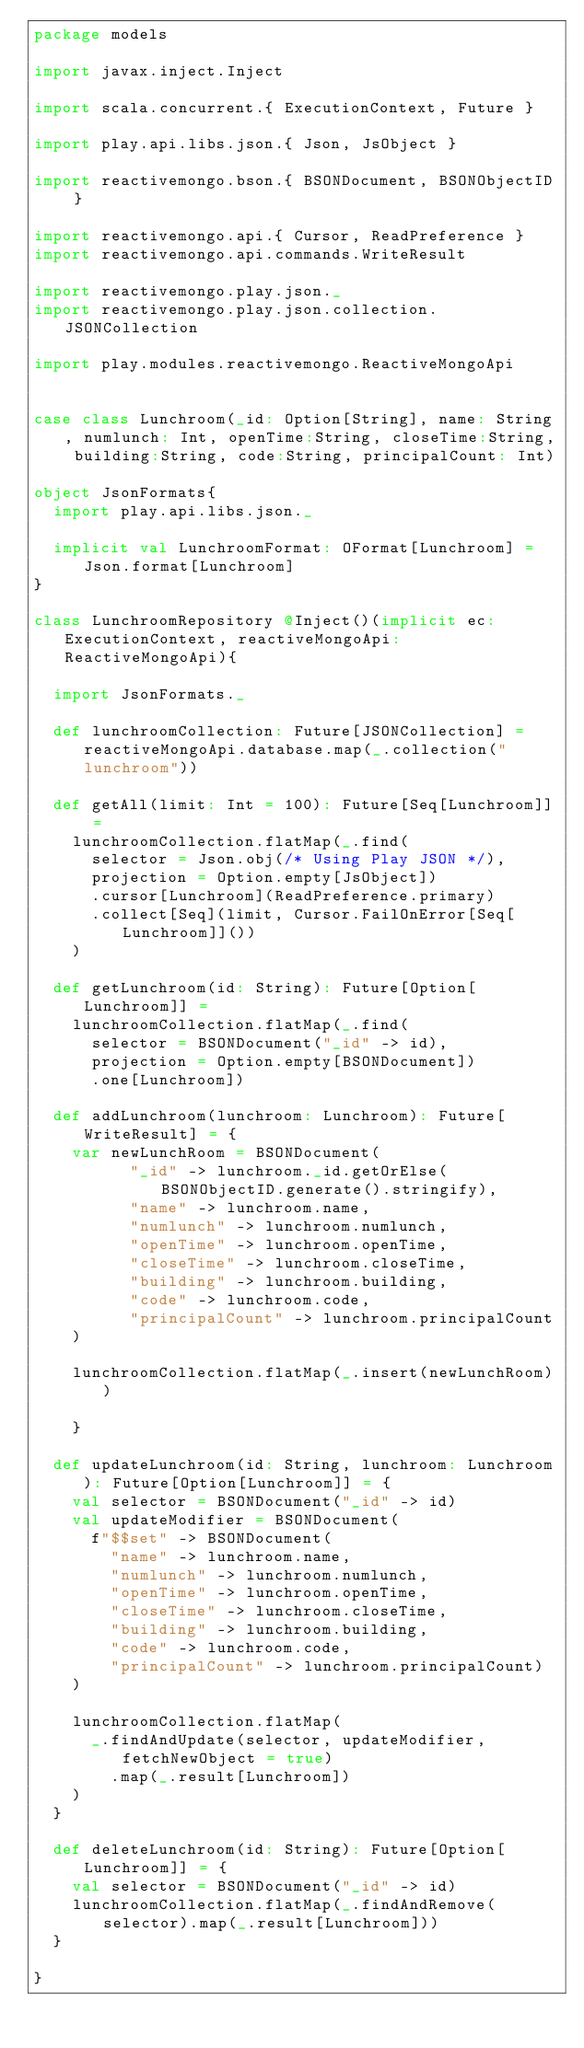<code> <loc_0><loc_0><loc_500><loc_500><_Scala_>package models

import javax.inject.Inject

import scala.concurrent.{ ExecutionContext, Future }

import play.api.libs.json.{ Json, JsObject }

import reactivemongo.bson.{ BSONDocument, BSONObjectID }

import reactivemongo.api.{ Cursor, ReadPreference }
import reactivemongo.api.commands.WriteResult

import reactivemongo.play.json._
import reactivemongo.play.json.collection.JSONCollection

import play.modules.reactivemongo.ReactiveMongoApi


case class Lunchroom(_id: Option[String], name: String, numlunch: Int, openTime:String, closeTime:String, building:String, code:String, principalCount: Int)

object JsonFormats{
  import play.api.libs.json._

  implicit val LunchroomFormat: OFormat[Lunchroom] = Json.format[Lunchroom]
}

class LunchroomRepository @Inject()(implicit ec: ExecutionContext, reactiveMongoApi: ReactiveMongoApi){

  import JsonFormats._

  def lunchroomCollection: Future[JSONCollection] = reactiveMongoApi.database.map(_.collection("lunchroom"))

  def getAll(limit: Int = 100): Future[Seq[Lunchroom]] =
    lunchroomCollection.flatMap(_.find(
      selector = Json.obj(/* Using Play JSON */),
      projection = Option.empty[JsObject])
      .cursor[Lunchroom](ReadPreference.primary)
      .collect[Seq](limit, Cursor.FailOnError[Seq[Lunchroom]]())
    )

  def getLunchroom(id: String): Future[Option[Lunchroom]] =
    lunchroomCollection.flatMap(_.find(
      selector = BSONDocument("_id" -> id),
      projection = Option.empty[BSONDocument])
      .one[Lunchroom])

  def addLunchroom(lunchroom: Lunchroom): Future[WriteResult] = {
    var newLunchRoom = BSONDocument(
          "_id" -> lunchroom._id.getOrElse(BSONObjectID.generate().stringify),
          "name" -> lunchroom.name,
          "numlunch" -> lunchroom.numlunch,
          "openTime" -> lunchroom.openTime,
          "closeTime" -> lunchroom.closeTime,
          "building" -> lunchroom.building,
          "code" -> lunchroom.code,
          "principalCount" -> lunchroom.principalCount
    )
    
    lunchroomCollection.flatMap(_.insert(newLunchRoom))

    }

  def updateLunchroom(id: String, lunchroom: Lunchroom): Future[Option[Lunchroom]] = {
    val selector = BSONDocument("_id" -> id)
    val updateModifier = BSONDocument(
      f"$$set" -> BSONDocument(
        "name" -> lunchroom.name,
        "numlunch" -> lunchroom.numlunch,
        "openTime" -> lunchroom.openTime,
        "closeTime" -> lunchroom.closeTime,
        "building" -> lunchroom.building,
        "code" -> lunchroom.code,
        "principalCount" -> lunchroom.principalCount)
    )

    lunchroomCollection.flatMap(
      _.findAndUpdate(selector, updateModifier, fetchNewObject = true)
        .map(_.result[Lunchroom])
    )
  }

  def deleteLunchroom(id: String): Future[Option[Lunchroom]] = {
    val selector = BSONDocument("_id" -> id)
    lunchroomCollection.flatMap(_.findAndRemove(selector).map(_.result[Lunchroom]))
  }

}
</code> 